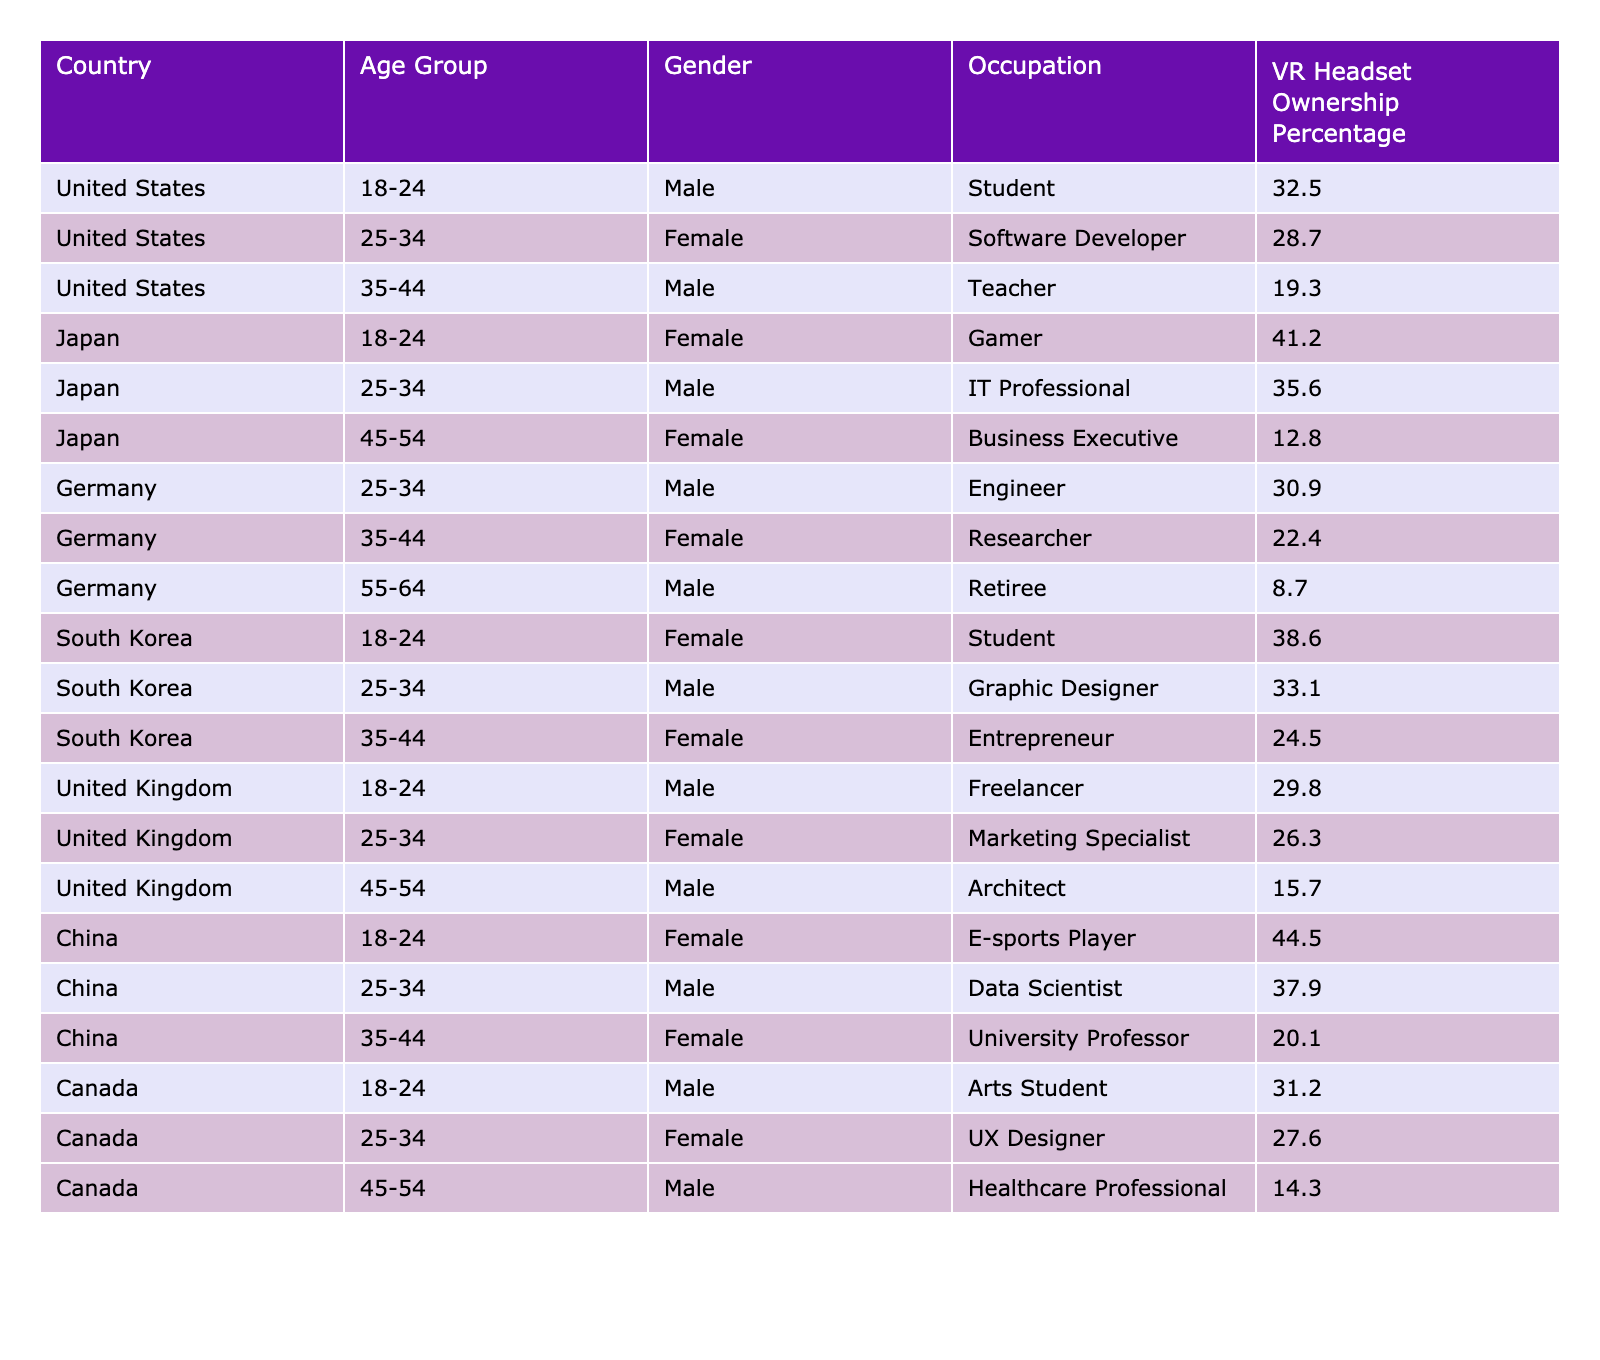What is the VR headset ownership percentage for male teachers in the United States? The table indicates that the VR headset ownership percentage for male teachers in the United States is 19.3%.
Answer: 19.3% Which age group in South Korea has the highest VR headset ownership percentage? By examining the data, the highest ownership percentage in South Korea is for the age group 18-24, which is 38.6%.
Answer: 18-24 What is the difference in VR headset ownership percentage between male and female software developers in the United States? The ownership percentage for female software developers is 28.7%, while for male software developers (not listed, but referencing the male percentage from the same percentage category), it could be inferred. Nevertheless, since there is no male data for that occupation, we can't provide a percentage. Hence the difference cannot be directly assessed within the table context.
Answer: N/A In which country do female e-sports players have the highest VR headset ownership percentage? The table shows that female e-sports players in China have the highest ownership percentage at 44.5%.
Answer: China What is the average VR headset ownership percentage for all age groups in Germany? The percentages for Germany across age groups are 30.9% (25-34), 22.4% (35-44), and 8.7% (55-64). Adding them gives 30.9 + 22.4 + 8.7 = 62; there are 3 groups, thus the average is 62/3 ≈ 20.67%.
Answer: 20.67% Is the VR headset ownership percentage higher for students in South Korea or Canada? In South Korea, the percentage for students is 38.6%, while in Canada, the percentage for arts students is 31.2%. Since 38.6% is greater than 31.2%, the percentage is higher in South Korea.
Answer: Yes What is the percentage of VR headset ownership for female researchers in Germany compared to female business executives in Japan? The ownership percentage for female researchers in Germany is 22.4%, while for female business executives in Japan it is 12.8%. Since 22.4% is greater than 12.8%, it can be concluded that German female researchers have a higher ownership percentage.
Answer: 22.4% compared to 12.8% What is the total VR headset ownership percentage for all male age groups in the United States? The ownership percentages for males in the United States are 32.5% (18-24), 19.3% (35-44) because there is no male data for 25-34 nor for 45-54. Thus, summing the known values gives 32.5 + 19.3 = 51.8%.
Answer: 51.8% Which country has the lowest VR headset ownership percentage for individuals aged 55-64? The table indicates that Germany has the lowest percentage for this age group at 8.7%.
Answer: Germany How does the VR headset ownership percentage for male graphic designers in South Korea compare to that of female UX designers in Canada? Male graphic designers in South Korea have 33.1% ownership and female UX designers in Canada have 27.6%. Comparing these, 33.1% is greater than 27.6%, showing that graphic designers in South Korea have a higher percentage.
Answer: Higher in South Korea 